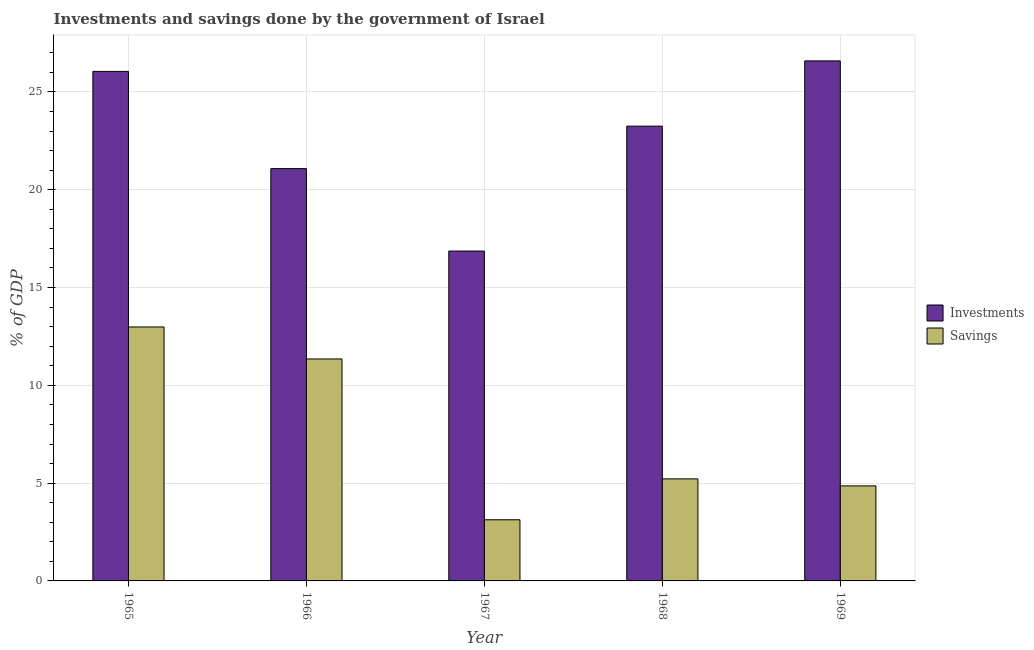How many different coloured bars are there?
Keep it short and to the point. 2. Are the number of bars per tick equal to the number of legend labels?
Your answer should be compact. Yes. Are the number of bars on each tick of the X-axis equal?
Your answer should be very brief. Yes. How many bars are there on the 4th tick from the right?
Your answer should be very brief. 2. What is the label of the 4th group of bars from the left?
Offer a terse response. 1968. In how many cases, is the number of bars for a given year not equal to the number of legend labels?
Give a very brief answer. 0. What is the savings of government in 1968?
Offer a very short reply. 5.22. Across all years, what is the maximum savings of government?
Provide a short and direct response. 12.98. Across all years, what is the minimum investments of government?
Offer a terse response. 16.87. In which year was the investments of government maximum?
Offer a terse response. 1969. In which year was the savings of government minimum?
Keep it short and to the point. 1967. What is the total savings of government in the graph?
Make the answer very short. 37.54. What is the difference between the investments of government in 1967 and that in 1969?
Ensure brevity in your answer.  -9.72. What is the difference between the savings of government in 1969 and the investments of government in 1965?
Your response must be concise. -8.12. What is the average investments of government per year?
Your answer should be very brief. 22.77. In how many years, is the investments of government greater than 5 %?
Keep it short and to the point. 5. What is the ratio of the savings of government in 1966 to that in 1968?
Your response must be concise. 2.18. Is the difference between the savings of government in 1966 and 1967 greater than the difference between the investments of government in 1966 and 1967?
Provide a succinct answer. No. What is the difference between the highest and the second highest investments of government?
Provide a succinct answer. 0.54. What is the difference between the highest and the lowest savings of government?
Offer a terse response. 9.86. In how many years, is the savings of government greater than the average savings of government taken over all years?
Offer a very short reply. 2. Is the sum of the investments of government in 1967 and 1968 greater than the maximum savings of government across all years?
Offer a terse response. Yes. What does the 1st bar from the left in 1969 represents?
Give a very brief answer. Investments. What does the 1st bar from the right in 1966 represents?
Provide a short and direct response. Savings. Are all the bars in the graph horizontal?
Provide a short and direct response. No. Are the values on the major ticks of Y-axis written in scientific E-notation?
Your answer should be very brief. No. Does the graph contain grids?
Your answer should be very brief. Yes. How many legend labels are there?
Offer a terse response. 2. What is the title of the graph?
Offer a terse response. Investments and savings done by the government of Israel. Does "Underweight" appear as one of the legend labels in the graph?
Provide a succinct answer. No. What is the label or title of the X-axis?
Your answer should be compact. Year. What is the label or title of the Y-axis?
Your answer should be very brief. % of GDP. What is the % of GDP in Investments in 1965?
Give a very brief answer. 26.05. What is the % of GDP in Savings in 1965?
Your answer should be very brief. 12.98. What is the % of GDP in Investments in 1966?
Make the answer very short. 21.08. What is the % of GDP of Savings in 1966?
Give a very brief answer. 11.35. What is the % of GDP of Investments in 1967?
Ensure brevity in your answer.  16.87. What is the % of GDP in Savings in 1967?
Your answer should be compact. 3.13. What is the % of GDP of Investments in 1968?
Your answer should be compact. 23.25. What is the % of GDP in Savings in 1968?
Keep it short and to the point. 5.22. What is the % of GDP in Investments in 1969?
Make the answer very short. 26.59. What is the % of GDP in Savings in 1969?
Offer a very short reply. 4.86. Across all years, what is the maximum % of GDP of Investments?
Give a very brief answer. 26.59. Across all years, what is the maximum % of GDP in Savings?
Offer a very short reply. 12.98. Across all years, what is the minimum % of GDP of Investments?
Make the answer very short. 16.87. Across all years, what is the minimum % of GDP in Savings?
Offer a terse response. 3.13. What is the total % of GDP of Investments in the graph?
Keep it short and to the point. 113.84. What is the total % of GDP of Savings in the graph?
Your answer should be very brief. 37.54. What is the difference between the % of GDP in Investments in 1965 and that in 1966?
Make the answer very short. 4.97. What is the difference between the % of GDP of Savings in 1965 and that in 1966?
Provide a succinct answer. 1.64. What is the difference between the % of GDP of Investments in 1965 and that in 1967?
Provide a succinct answer. 9.19. What is the difference between the % of GDP of Savings in 1965 and that in 1967?
Offer a terse response. 9.86. What is the difference between the % of GDP in Investments in 1965 and that in 1968?
Your answer should be very brief. 2.8. What is the difference between the % of GDP in Savings in 1965 and that in 1968?
Ensure brevity in your answer.  7.77. What is the difference between the % of GDP in Investments in 1965 and that in 1969?
Offer a terse response. -0.54. What is the difference between the % of GDP of Savings in 1965 and that in 1969?
Ensure brevity in your answer.  8.12. What is the difference between the % of GDP of Investments in 1966 and that in 1967?
Your answer should be compact. 4.22. What is the difference between the % of GDP in Savings in 1966 and that in 1967?
Provide a succinct answer. 8.22. What is the difference between the % of GDP in Investments in 1966 and that in 1968?
Give a very brief answer. -2.17. What is the difference between the % of GDP of Savings in 1966 and that in 1968?
Your response must be concise. 6.13. What is the difference between the % of GDP of Investments in 1966 and that in 1969?
Your answer should be very brief. -5.51. What is the difference between the % of GDP of Savings in 1966 and that in 1969?
Your response must be concise. 6.49. What is the difference between the % of GDP in Investments in 1967 and that in 1968?
Provide a short and direct response. -6.39. What is the difference between the % of GDP of Savings in 1967 and that in 1968?
Offer a very short reply. -2.09. What is the difference between the % of GDP in Investments in 1967 and that in 1969?
Offer a terse response. -9.72. What is the difference between the % of GDP in Savings in 1967 and that in 1969?
Make the answer very short. -1.73. What is the difference between the % of GDP of Investments in 1968 and that in 1969?
Your response must be concise. -3.34. What is the difference between the % of GDP in Savings in 1968 and that in 1969?
Keep it short and to the point. 0.36. What is the difference between the % of GDP of Investments in 1965 and the % of GDP of Savings in 1966?
Provide a succinct answer. 14.7. What is the difference between the % of GDP of Investments in 1965 and the % of GDP of Savings in 1967?
Provide a short and direct response. 22.92. What is the difference between the % of GDP of Investments in 1965 and the % of GDP of Savings in 1968?
Offer a very short reply. 20.83. What is the difference between the % of GDP of Investments in 1965 and the % of GDP of Savings in 1969?
Make the answer very short. 21.19. What is the difference between the % of GDP of Investments in 1966 and the % of GDP of Savings in 1967?
Your answer should be compact. 17.95. What is the difference between the % of GDP in Investments in 1966 and the % of GDP in Savings in 1968?
Your response must be concise. 15.86. What is the difference between the % of GDP of Investments in 1966 and the % of GDP of Savings in 1969?
Your answer should be very brief. 16.22. What is the difference between the % of GDP of Investments in 1967 and the % of GDP of Savings in 1968?
Make the answer very short. 11.65. What is the difference between the % of GDP in Investments in 1967 and the % of GDP in Savings in 1969?
Your response must be concise. 12.01. What is the difference between the % of GDP of Investments in 1968 and the % of GDP of Savings in 1969?
Provide a short and direct response. 18.39. What is the average % of GDP of Investments per year?
Offer a terse response. 22.77. What is the average % of GDP of Savings per year?
Keep it short and to the point. 7.51. In the year 1965, what is the difference between the % of GDP in Investments and % of GDP in Savings?
Your answer should be compact. 13.07. In the year 1966, what is the difference between the % of GDP in Investments and % of GDP in Savings?
Give a very brief answer. 9.73. In the year 1967, what is the difference between the % of GDP of Investments and % of GDP of Savings?
Your answer should be compact. 13.74. In the year 1968, what is the difference between the % of GDP in Investments and % of GDP in Savings?
Give a very brief answer. 18.03. In the year 1969, what is the difference between the % of GDP in Investments and % of GDP in Savings?
Your answer should be compact. 21.73. What is the ratio of the % of GDP in Investments in 1965 to that in 1966?
Give a very brief answer. 1.24. What is the ratio of the % of GDP of Savings in 1965 to that in 1966?
Ensure brevity in your answer.  1.14. What is the ratio of the % of GDP of Investments in 1965 to that in 1967?
Your response must be concise. 1.54. What is the ratio of the % of GDP of Savings in 1965 to that in 1967?
Provide a succinct answer. 4.15. What is the ratio of the % of GDP of Investments in 1965 to that in 1968?
Make the answer very short. 1.12. What is the ratio of the % of GDP of Savings in 1965 to that in 1968?
Offer a terse response. 2.49. What is the ratio of the % of GDP of Investments in 1965 to that in 1969?
Make the answer very short. 0.98. What is the ratio of the % of GDP of Savings in 1965 to that in 1969?
Provide a short and direct response. 2.67. What is the ratio of the % of GDP in Investments in 1966 to that in 1967?
Offer a terse response. 1.25. What is the ratio of the % of GDP in Savings in 1966 to that in 1967?
Provide a succinct answer. 3.63. What is the ratio of the % of GDP of Investments in 1966 to that in 1968?
Provide a succinct answer. 0.91. What is the ratio of the % of GDP of Savings in 1966 to that in 1968?
Offer a terse response. 2.17. What is the ratio of the % of GDP of Investments in 1966 to that in 1969?
Offer a terse response. 0.79. What is the ratio of the % of GDP in Savings in 1966 to that in 1969?
Make the answer very short. 2.34. What is the ratio of the % of GDP of Investments in 1967 to that in 1968?
Give a very brief answer. 0.73. What is the ratio of the % of GDP of Savings in 1967 to that in 1968?
Your answer should be very brief. 0.6. What is the ratio of the % of GDP in Investments in 1967 to that in 1969?
Provide a succinct answer. 0.63. What is the ratio of the % of GDP of Savings in 1967 to that in 1969?
Your answer should be very brief. 0.64. What is the ratio of the % of GDP of Investments in 1968 to that in 1969?
Provide a succinct answer. 0.87. What is the ratio of the % of GDP of Savings in 1968 to that in 1969?
Keep it short and to the point. 1.07. What is the difference between the highest and the second highest % of GDP of Investments?
Your response must be concise. 0.54. What is the difference between the highest and the second highest % of GDP of Savings?
Provide a succinct answer. 1.64. What is the difference between the highest and the lowest % of GDP of Investments?
Keep it short and to the point. 9.72. What is the difference between the highest and the lowest % of GDP of Savings?
Offer a very short reply. 9.86. 